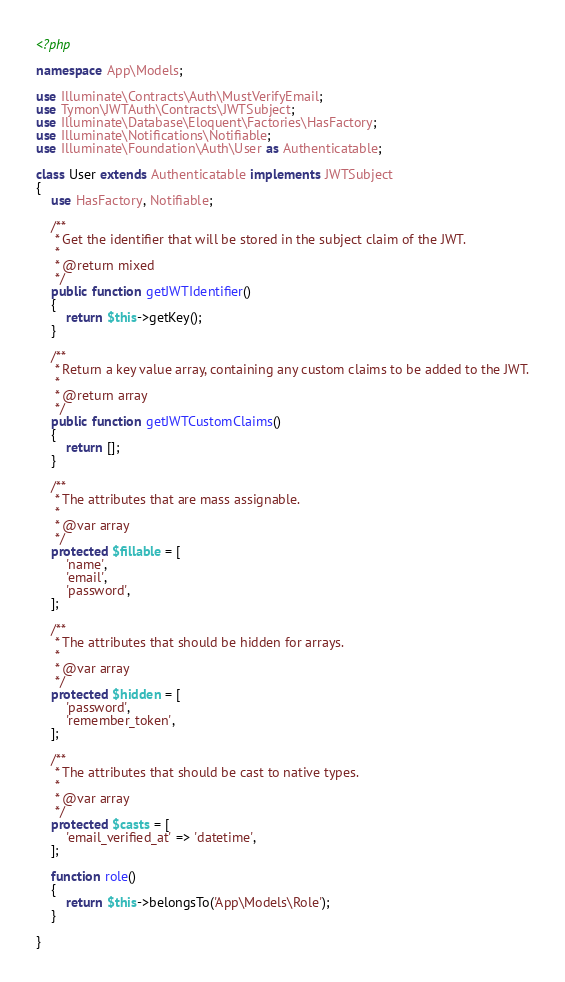<code> <loc_0><loc_0><loc_500><loc_500><_PHP_><?php

namespace App\Models;

use Illuminate\Contracts\Auth\MustVerifyEmail;
use Tymon\JWTAuth\Contracts\JWTSubject;
use Illuminate\Database\Eloquent\Factories\HasFactory;
use Illuminate\Notifications\Notifiable;
use Illuminate\Foundation\Auth\User as Authenticatable;

class User extends Authenticatable implements JWTSubject
{
    use HasFactory, Notifiable;

    /**
     * Get the identifier that will be stored in the subject claim of the JWT.
     *
     * @return mixed
     */
    public function getJWTIdentifier()
    {
        return $this->getKey();
    }

    /**
     * Return a key value array, containing any custom claims to be added to the JWT.
     *
     * @return array
     */
    public function getJWTCustomClaims()
    {
        return [];
    }

    /**
     * The attributes that are mass assignable.
     *
     * @var array
     */
    protected $fillable = [
        'name',
        'email',
        'password',
    ];

    /**
     * The attributes that should be hidden for arrays.
     *
     * @var array
     */
    protected $hidden = [
        'password',
        'remember_token',
    ];

    /**
     * The attributes that should be cast to native types.
     *
     * @var array
     */
    protected $casts = [
        'email_verified_at' => 'datetime',
    ];

    function role()
    {
        return $this->belongsTo('App\Models\Role');
    }

}
</code> 